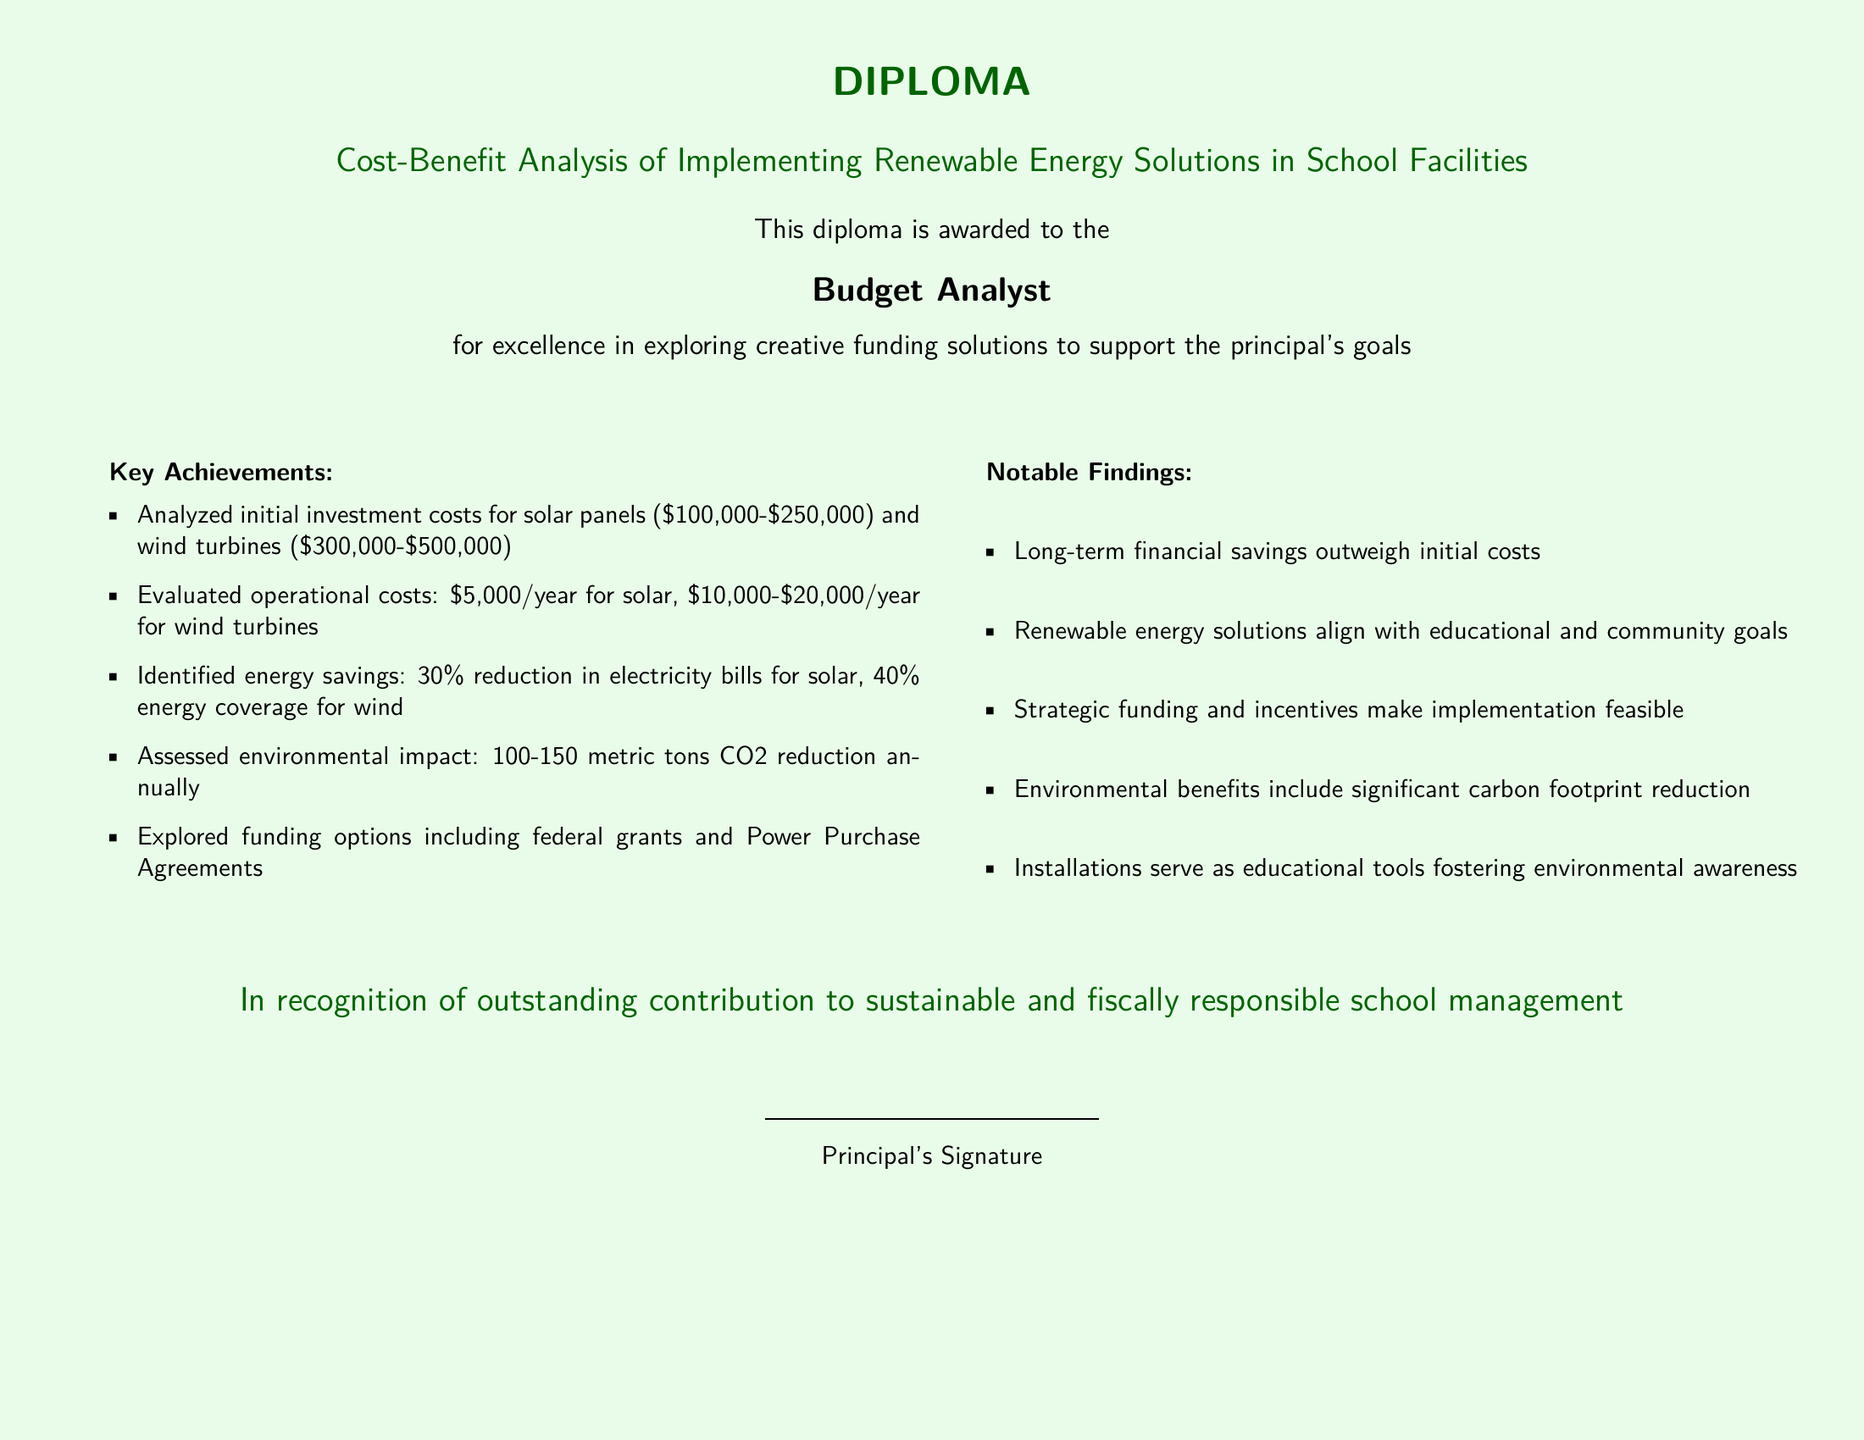What is the cost range for solar panels? The document states the initial investment costs for solar panels as $100,000 to $250,000.
Answer: $100,000-$250,000 What is the annual operational cost for wind turbines? According to the document, the operational cost for wind turbines ranges from $10,000 to $20,000 per year.
Answer: $10,000-$20,000 How much can energy bills be reduced by implementing solar panels? The document indicates a 30% reduction in electricity bills for schools that implement solar solutions.
Answer: 30% What is the annual reduction in CO2 emissions? The diploma mentions a reduction in 100 to 150 metric tons of CO2 emissions annually.
Answer: 100-150 metric tons What funding options are explored? The document lists federal grants and Power Purchase Agreements as potential funding options explored.
Answer: Federal grants and Power Purchase Agreements What is emphasized about the long-term financial perspective? The document states that long-term financial savings outweigh the initial costs of renewable energy implementation.
Answer: Long-term financial savings How do renewable energy solutions align with school goals? The document indicates that renewable energy solutions align with educational and community goals.
Answer: Educational and community goals Who awards this diploma? The document notes that the diploma is awarded by the Principal.
Answer: Principal 